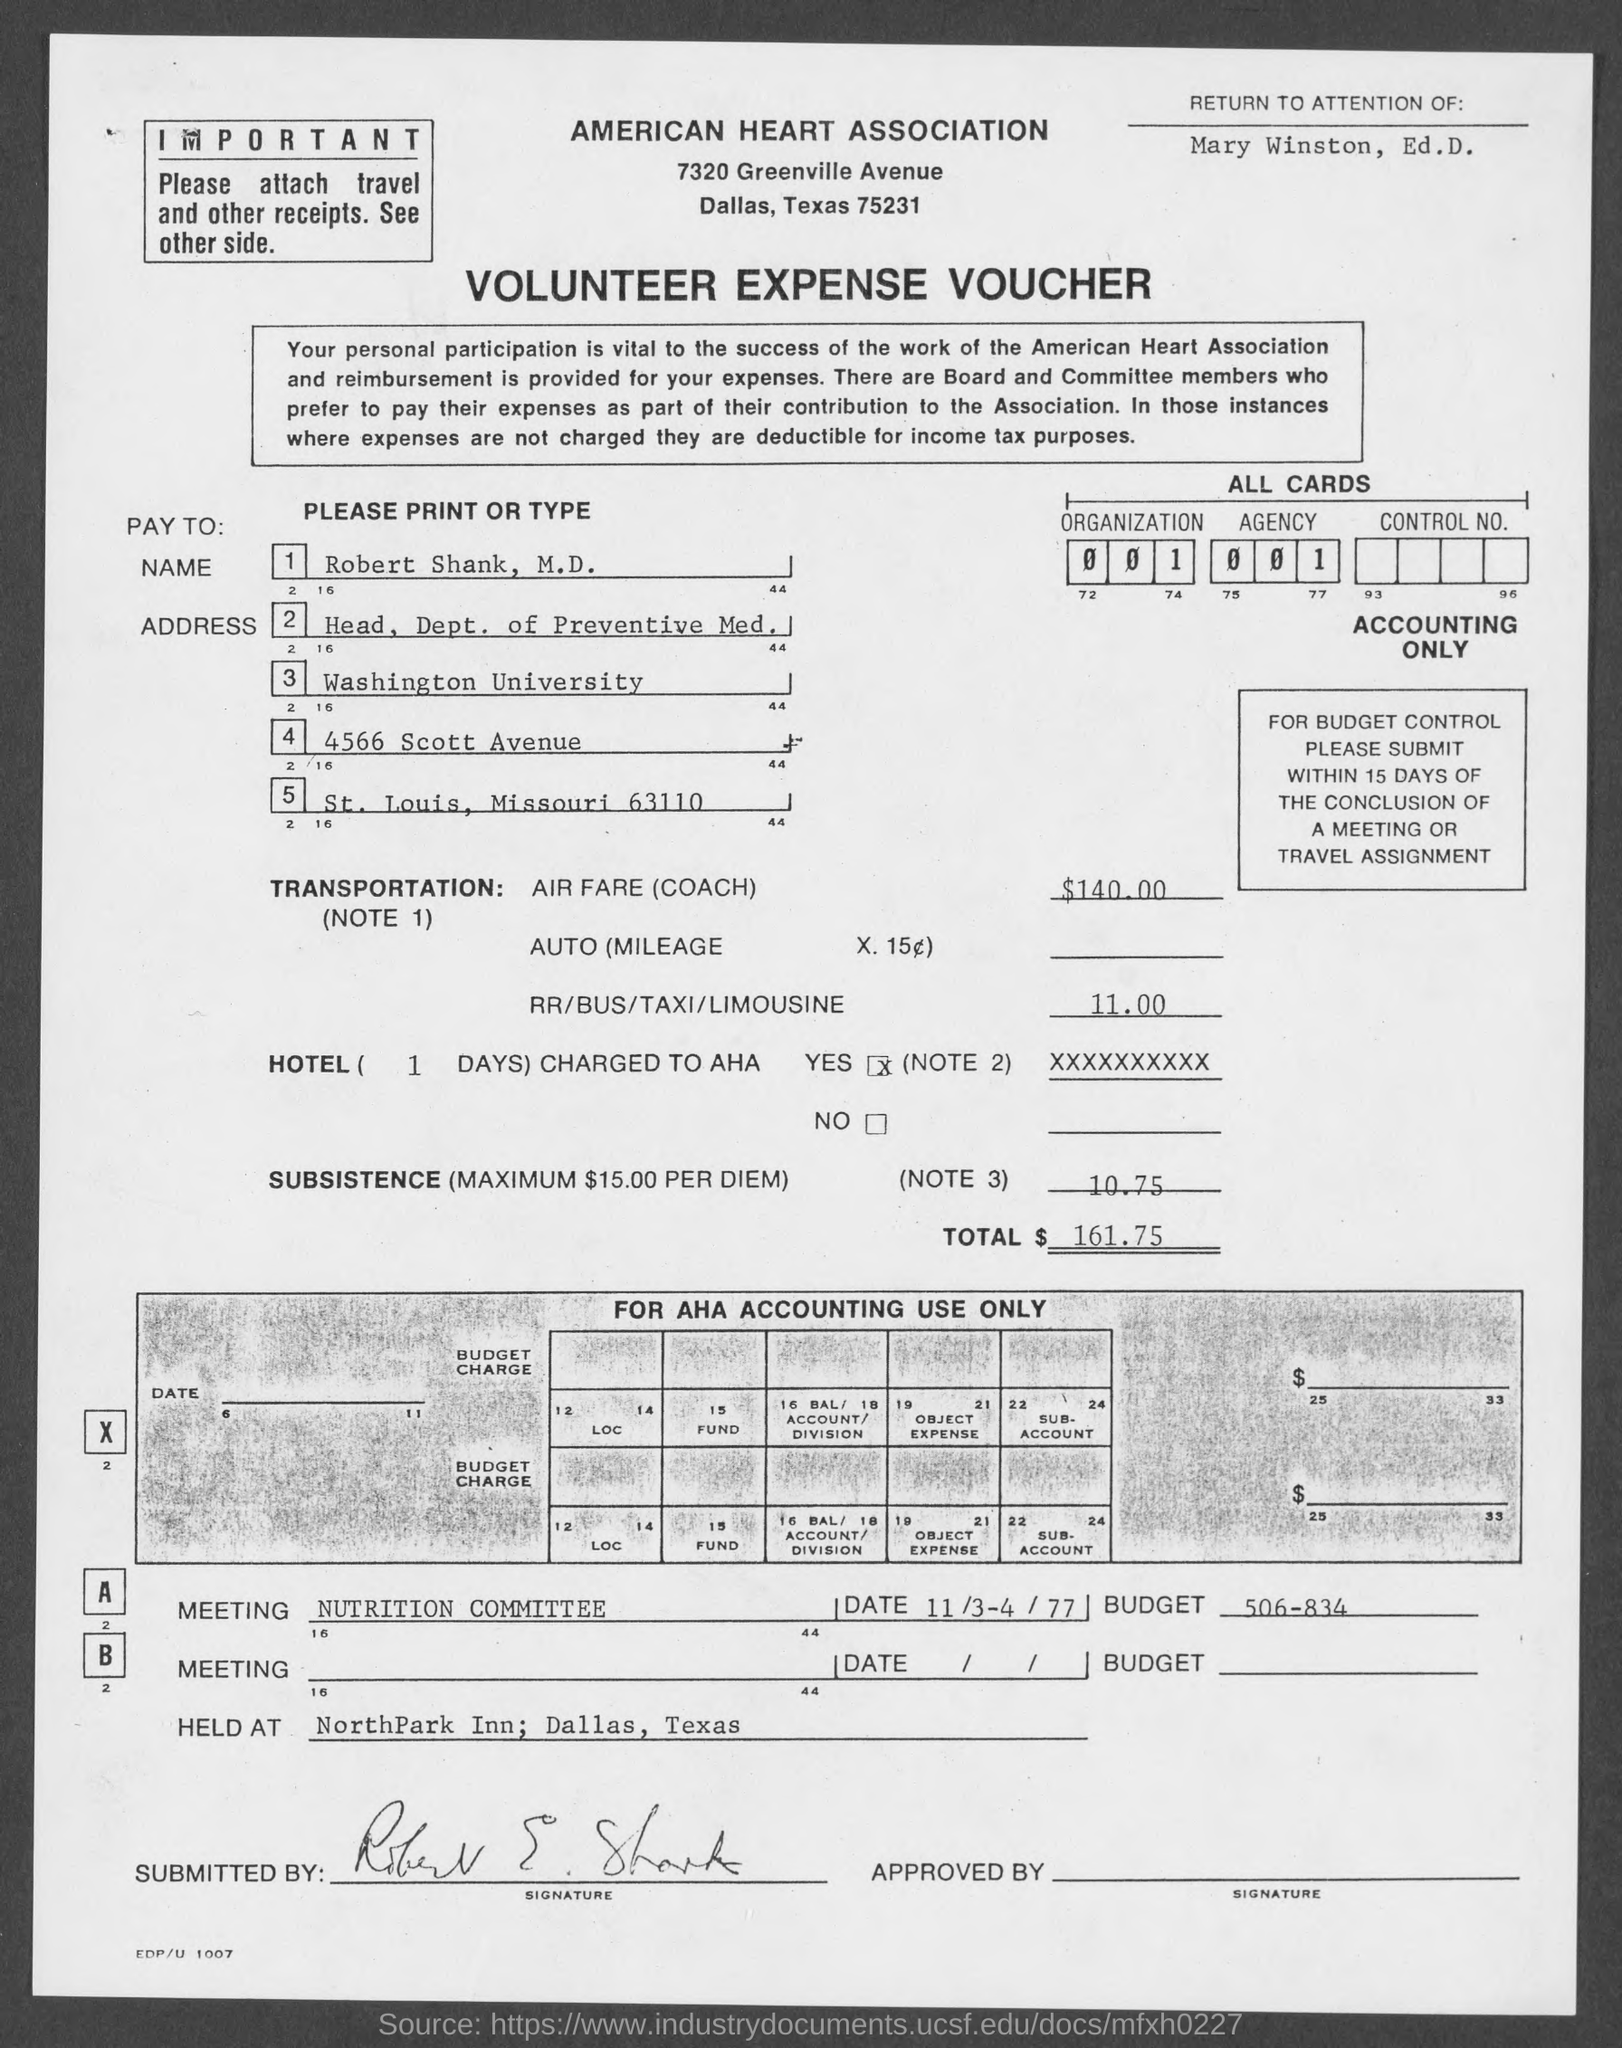Give some essential details in this illustration. The title of the document is 'Volunteer Expense Voucher.' The total is 161.75. The airfare is $140.00. The fare for RR/BUS/TAXI/LIMOUSINE is 11.00 What is the subsistence rate? 10.75..." is a question asking for information about the rate at which something is subsistence. 